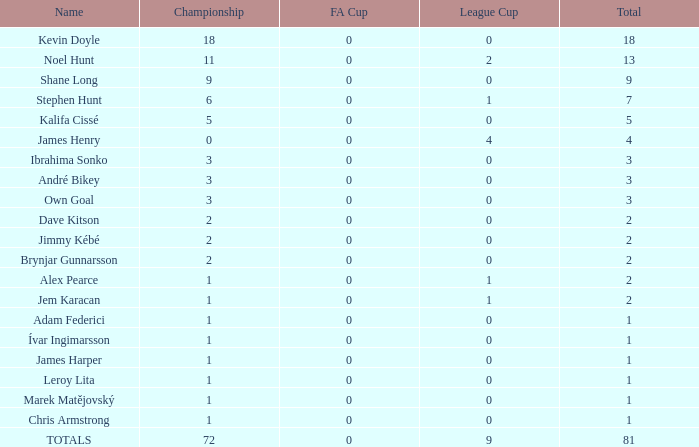What is the overall number of titles james henry holds with more than one league cup? 0.0. 